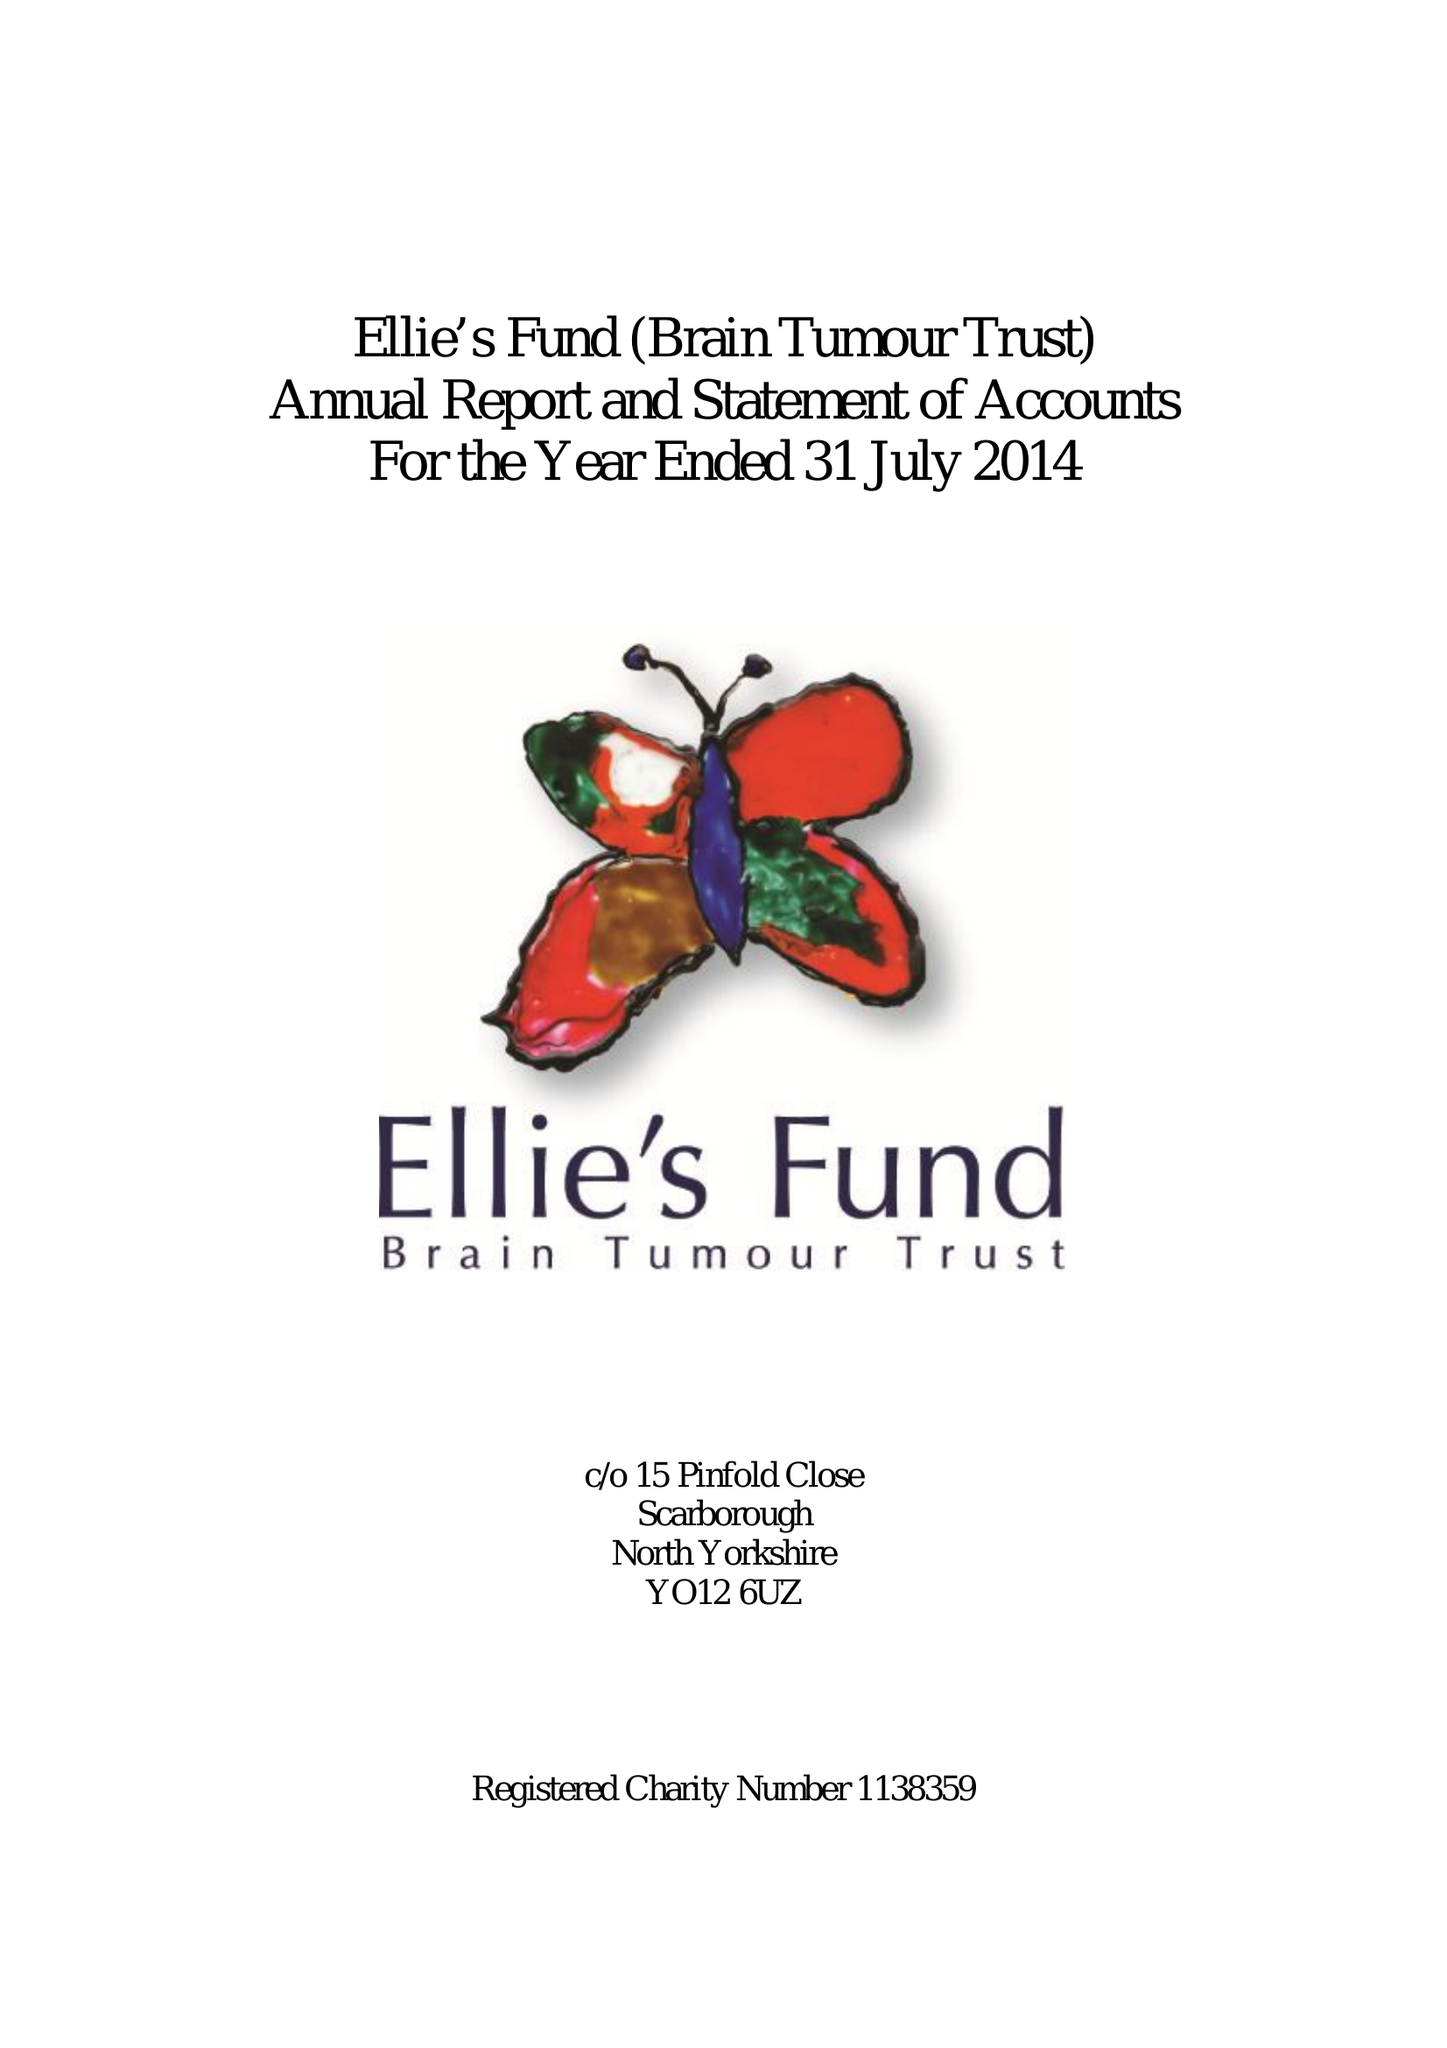What is the value for the address__postcode?
Answer the question using a single word or phrase. None 